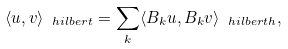Convert formula to latex. <formula><loc_0><loc_0><loc_500><loc_500>\langle u , v \rangle _ { \ h i l b e r t } = \sum _ { k } \langle B _ { k } u , B _ { k } v \rangle _ { \ h i l b e r t h } ,</formula> 